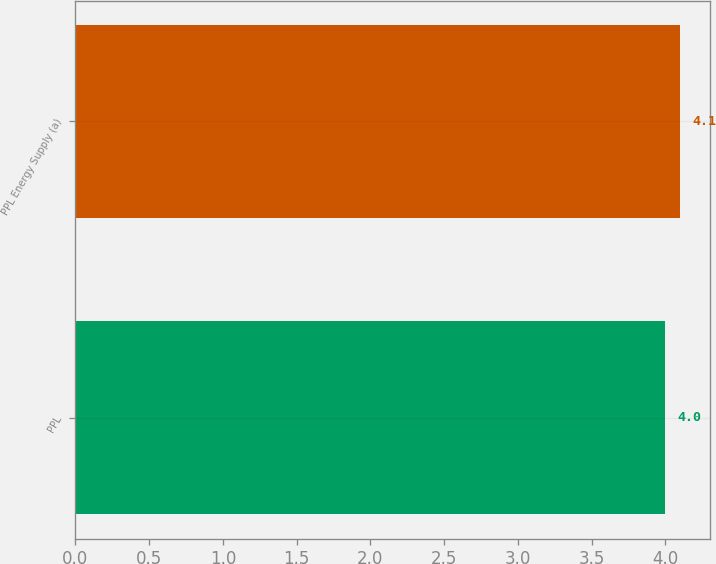Convert chart. <chart><loc_0><loc_0><loc_500><loc_500><bar_chart><fcel>PPL<fcel>PPL Energy Supply (a)<nl><fcel>4<fcel>4.1<nl></chart> 